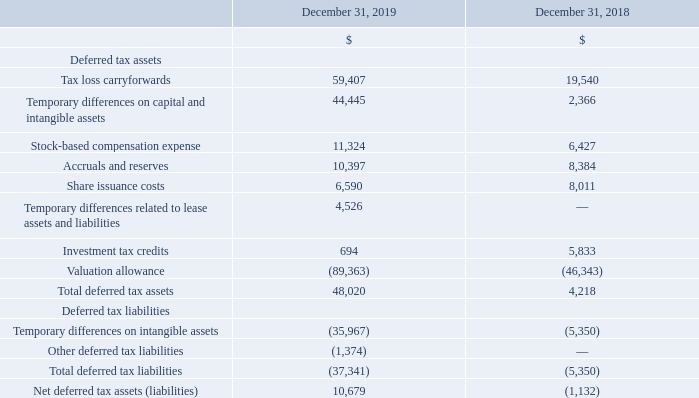The significant components of the Company’s deferred income tax assets and liabilities as of December 31, 2019 and 2018 are as follows:
In July 2019, the Company formally established its EMEA headquarters in Ireland and its Asia-Pacific headquarters in Singapore. As a result of these actions, the Company transferred regional relationship and territory rights from its Canadian entity to enable each regional headquarters to develop and maintain merchant and commercial operations within its respective region, while keeping the ownership of all of the Company's current developed technology within Canada. These transfers reflect the growing proportion of the Company's business occurring internationally and resulted in a one-time capital gain. As a result of the capital gain, ongoing operations, the recognition of deferred tax assets and liabilities, and the utilization of all applicable credits and other tax attributes, including loss carryforwards, the Company has a provision for income taxes of $29,027 in the year ended December 31, 2019.
During the year ended December 31, 2019, the Company released some of its valuation allowance against its deferred tax assets in Canada, the United States, and Sweden. In the third quarter of 2019, the Company released a portion of its valuation allowance against its Canadian deferred tax assets as a result of the capital gain from the transfer of the regional relationship and territory rights. In the United States, as a result of the acquisition of 6RS the Company released a portion of its valuation allowance during its fourth quarter against deferred tax assets on its United States net operating losses.
The Company has provided for deferred income taxes for the estimated tax cost of distributable earnings of its subsidiaries of $292.
The Company had no material uncertain income tax positions for the years ended December 31, 2019 and 2018. The Company's accounting policy is to recognize interest and penalties related to uncertain tax positions as a component of income tax expense. In the years ended December 31, 2019 and 2018, there was no interest or penalties related to uncertain tax positions.
The Company remains subject to audit by the relevant tax authorities for the years ended 2012 through 2019.
Investment tax credits, which are earned as a result of qualifying R&D expenditures, are recognized and applied to reduce income tax expense in the year in which the expenditures are made and their realization is reasonably assured.
As at December 31, 2019 and 2018, the Company had unused non-capital tax losses of approximately $209,759 and $53,941 respectively. Of the December 31, 2019 balance, $150,707 of the non-capital tax losses do not expire, while the remaining non-capital losses of $59,052 are due to expire between 2033 and 2039. The Company has U.S. state losses of $298,998 as at December 31, 2019 (December 31, 2018 - $116,026). There is no SR&ED expenditure pool balance as at December 31, 2019 (December 31, 2018 - $9,575). In addition, at December 31, 2019 and 2018, the Company had investment tax credits of $2,111 and $4,179, respectively. The investment tax credits are due to expire between 2035 and 2039.
Expressed in US $000's except share and per share amounts
What financial items does deferred tax assets comprise of? Tax loss carryforwards, temporary differences on capital and intangible assets, stock-based compensation expense, accruals and reserves, share issuance costs, temporary differences related to lease assets and liabilities, investment tax credits, valuation allowance. What financial items does deferred tax liabilities comprise of? Temporary differences on intangible assets, other deferred tax liabilities. What is the total deferred tax liabilities as at December 31, 2019?
Answer scale should be: thousand. (37,341). What is the average total deferred tax assets for 2018 and 2019?
Answer scale should be: thousand. (48,020+4,218)/2
Answer: 26119. What is the average total deferred tax liabilities for 2018 and 2019?
Answer scale should be: thousand. [(-37,341) + (-5,350)] /2
Answer: -21345.5. Which year has the highest total deferred tax assets? 48,020> 4,218
Answer: 2019. 